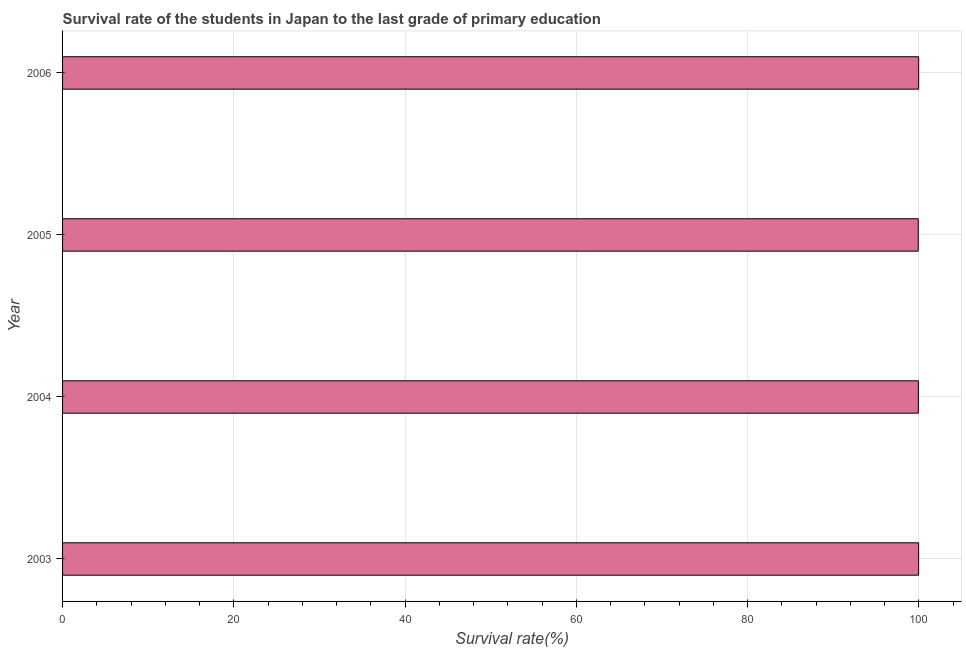What is the title of the graph?
Make the answer very short. Survival rate of the students in Japan to the last grade of primary education. What is the label or title of the X-axis?
Provide a short and direct response. Survival rate(%). What is the label or title of the Y-axis?
Keep it short and to the point. Year. What is the survival rate in primary education in 2003?
Offer a very short reply. 99.97. Across all years, what is the maximum survival rate in primary education?
Your response must be concise. 99.97. Across all years, what is the minimum survival rate in primary education?
Offer a terse response. 99.92. In which year was the survival rate in primary education maximum?
Offer a terse response. 2006. What is the sum of the survival rate in primary education?
Ensure brevity in your answer.  399.79. What is the difference between the survival rate in primary education in 2003 and 2005?
Provide a short and direct response. 0.05. What is the average survival rate in primary education per year?
Give a very brief answer. 99.95. What is the median survival rate in primary education?
Give a very brief answer. 99.95. In how many years, is the survival rate in primary education greater than 96 %?
Offer a very short reply. 4. Do a majority of the years between 2003 and 2005 (inclusive) have survival rate in primary education greater than 100 %?
Your answer should be compact. No. Is the survival rate in primary education in 2004 less than that in 2005?
Ensure brevity in your answer.  No. Is the difference between the survival rate in primary education in 2003 and 2006 greater than the difference between any two years?
Keep it short and to the point. No. What is the difference between the highest and the second highest survival rate in primary education?
Offer a terse response. 0.01. Is the sum of the survival rate in primary education in 2004 and 2005 greater than the maximum survival rate in primary education across all years?
Make the answer very short. Yes. How many bars are there?
Give a very brief answer. 4. Are all the bars in the graph horizontal?
Provide a succinct answer. Yes. What is the difference between two consecutive major ticks on the X-axis?
Your answer should be very brief. 20. What is the Survival rate(%) of 2003?
Your answer should be compact. 99.97. What is the Survival rate(%) of 2004?
Keep it short and to the point. 99.93. What is the Survival rate(%) of 2005?
Offer a terse response. 99.92. What is the Survival rate(%) in 2006?
Provide a succinct answer. 99.97. What is the difference between the Survival rate(%) in 2003 and 2004?
Your response must be concise. 0.03. What is the difference between the Survival rate(%) in 2003 and 2005?
Provide a succinct answer. 0.05. What is the difference between the Survival rate(%) in 2003 and 2006?
Give a very brief answer. -0.01. What is the difference between the Survival rate(%) in 2004 and 2005?
Provide a short and direct response. 0.01. What is the difference between the Survival rate(%) in 2004 and 2006?
Offer a terse response. -0.04. What is the difference between the Survival rate(%) in 2005 and 2006?
Give a very brief answer. -0.05. What is the ratio of the Survival rate(%) in 2003 to that in 2004?
Provide a short and direct response. 1. What is the ratio of the Survival rate(%) in 2003 to that in 2005?
Your answer should be very brief. 1. What is the ratio of the Survival rate(%) in 2003 to that in 2006?
Keep it short and to the point. 1. What is the ratio of the Survival rate(%) in 2004 to that in 2006?
Your response must be concise. 1. What is the ratio of the Survival rate(%) in 2005 to that in 2006?
Offer a very short reply. 1. 